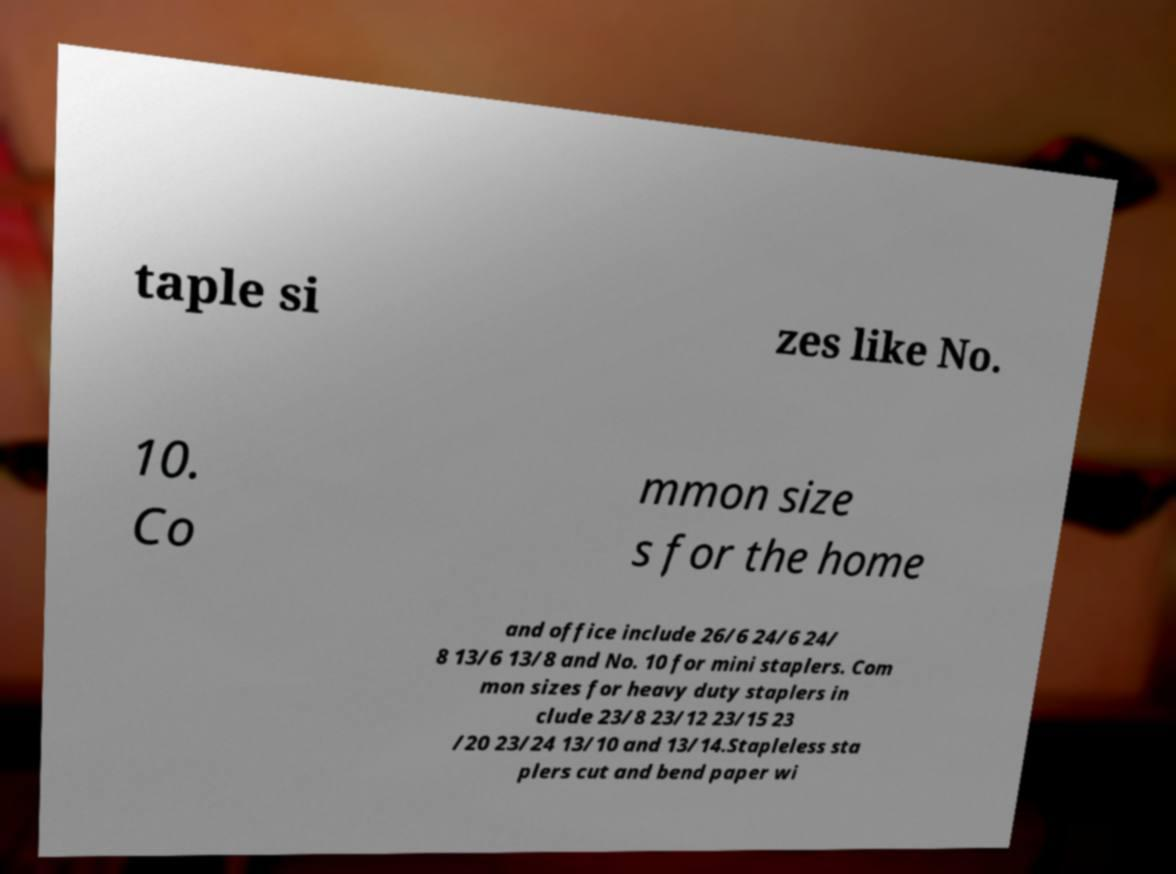Please identify and transcribe the text found in this image. taple si zes like No. 10. Co mmon size s for the home and office include 26/6 24/6 24/ 8 13/6 13/8 and No. 10 for mini staplers. Com mon sizes for heavy duty staplers in clude 23/8 23/12 23/15 23 /20 23/24 13/10 and 13/14.Stapleless sta plers cut and bend paper wi 